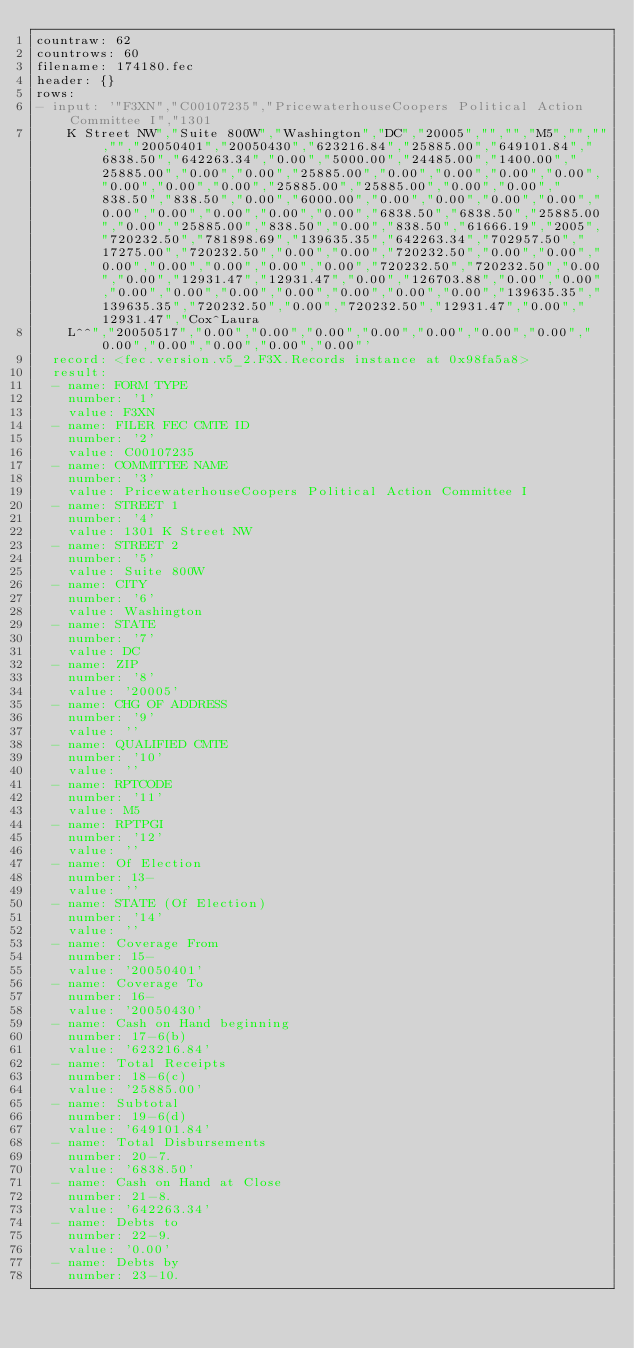<code> <loc_0><loc_0><loc_500><loc_500><_YAML_>countraw: 62
countrows: 60
filename: 174180.fec
header: {}
rows:
- input: '"F3XN","C00107235","PricewaterhouseCoopers Political Action Committee I","1301
    K Street NW","Suite 800W","Washington","DC","20005","","","M5","","","","20050401","20050430","623216.84","25885.00","649101.84","6838.50","642263.34","0.00","5000.00","24485.00","1400.00","25885.00","0.00","0.00","25885.00","0.00","0.00","0.00","0.00","0.00","0.00","0.00","25885.00","25885.00","0.00","0.00","838.50","838.50","0.00","6000.00","0.00","0.00","0.00","0.00","0.00","0.00","0.00","0.00","0.00","6838.50","6838.50","25885.00","0.00","25885.00","838.50","0.00","838.50","61666.19","2005","720232.50","781898.69","139635.35","642263.34","702957.50","17275.00","720232.50","0.00","0.00","720232.50","0.00","0.00","0.00","0.00","0.00","0.00","0.00","720232.50","720232.50","0.00","0.00","12931.47","12931.47","0.00","126703.88","0.00","0.00","0.00","0.00","0.00","0.00","0.00","0.00","0.00","139635.35","139635.35","720232.50","0.00","720232.50","12931.47","0.00","12931.47","Cox^Laura
    L^^","20050517","0.00","0.00","0.00","0.00","0.00","0.00","0.00","0.00","0.00","0.00","0.00","0.00"'
  record: <fec.version.v5_2.F3X.Records instance at 0x98fa5a8>
  result:
  - name: FORM TYPE
    number: '1'
    value: F3XN
  - name: FILER FEC CMTE ID
    number: '2'
    value: C00107235
  - name: COMMITTEE NAME
    number: '3'
    value: PricewaterhouseCoopers Political Action Committee I
  - name: STREET 1
    number: '4'
    value: 1301 K Street NW
  - name: STREET 2
    number: '5'
    value: Suite 800W
  - name: CITY
    number: '6'
    value: Washington
  - name: STATE
    number: '7'
    value: DC
  - name: ZIP
    number: '8'
    value: '20005'
  - name: CHG OF ADDRESS
    number: '9'
    value: ''
  - name: QUALIFIED CMTE
    number: '10'
    value: ''
  - name: RPTCODE
    number: '11'
    value: M5
  - name: RPTPGI
    number: '12'
    value: ''
  - name: Of Election
    number: 13-
    value: ''
  - name: STATE (Of Election)
    number: '14'
    value: ''
  - name: Coverage From
    number: 15-
    value: '20050401'
  - name: Coverage To
    number: 16-
    value: '20050430'
  - name: Cash on Hand beginning
    number: 17-6(b)
    value: '623216.84'
  - name: Total Receipts
    number: 18-6(c)
    value: '25885.00'
  - name: Subtotal
    number: 19-6(d)
    value: '649101.84'
  - name: Total Disbursements
    number: 20-7.
    value: '6838.50'
  - name: Cash on Hand at Close
    number: 21-8.
    value: '642263.34'
  - name: Debts to
    number: 22-9.
    value: '0.00'
  - name: Debts by
    number: 23-10.</code> 